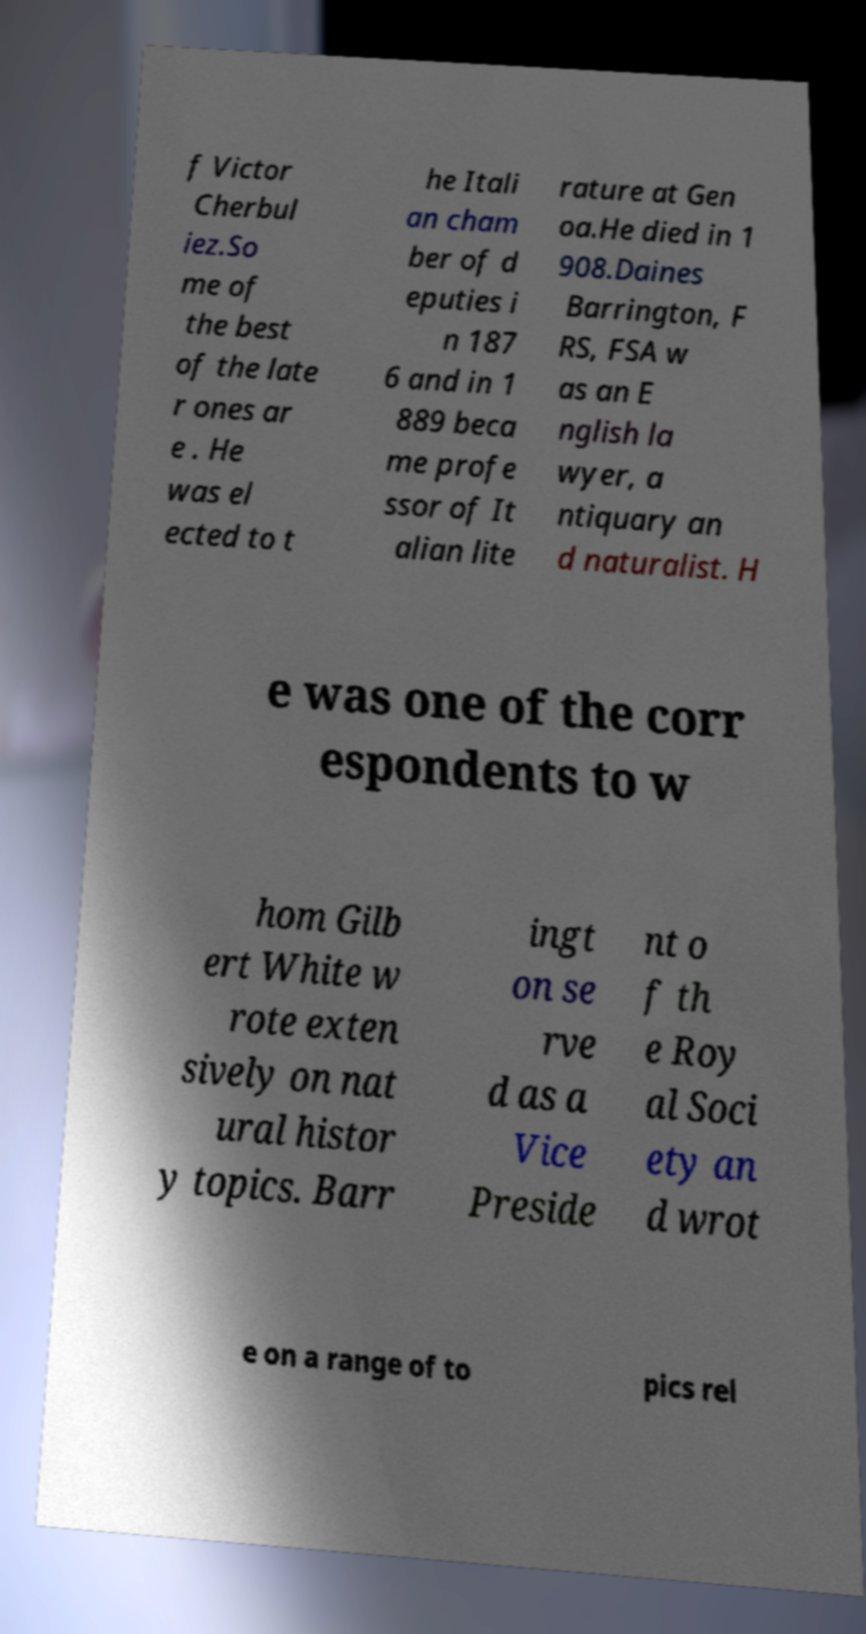Could you assist in decoding the text presented in this image and type it out clearly? f Victor Cherbul iez.So me of the best of the late r ones ar e . He was el ected to t he Itali an cham ber of d eputies i n 187 6 and in 1 889 beca me profe ssor of It alian lite rature at Gen oa.He died in 1 908.Daines Barrington, F RS, FSA w as an E nglish la wyer, a ntiquary an d naturalist. H e was one of the corr espondents to w hom Gilb ert White w rote exten sively on nat ural histor y topics. Barr ingt on se rve d as a Vice Preside nt o f th e Roy al Soci ety an d wrot e on a range of to pics rel 